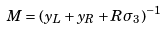<formula> <loc_0><loc_0><loc_500><loc_500>M = ( y _ { L } + y _ { R } + R \sigma _ { 3 } ) ^ { - 1 }</formula> 